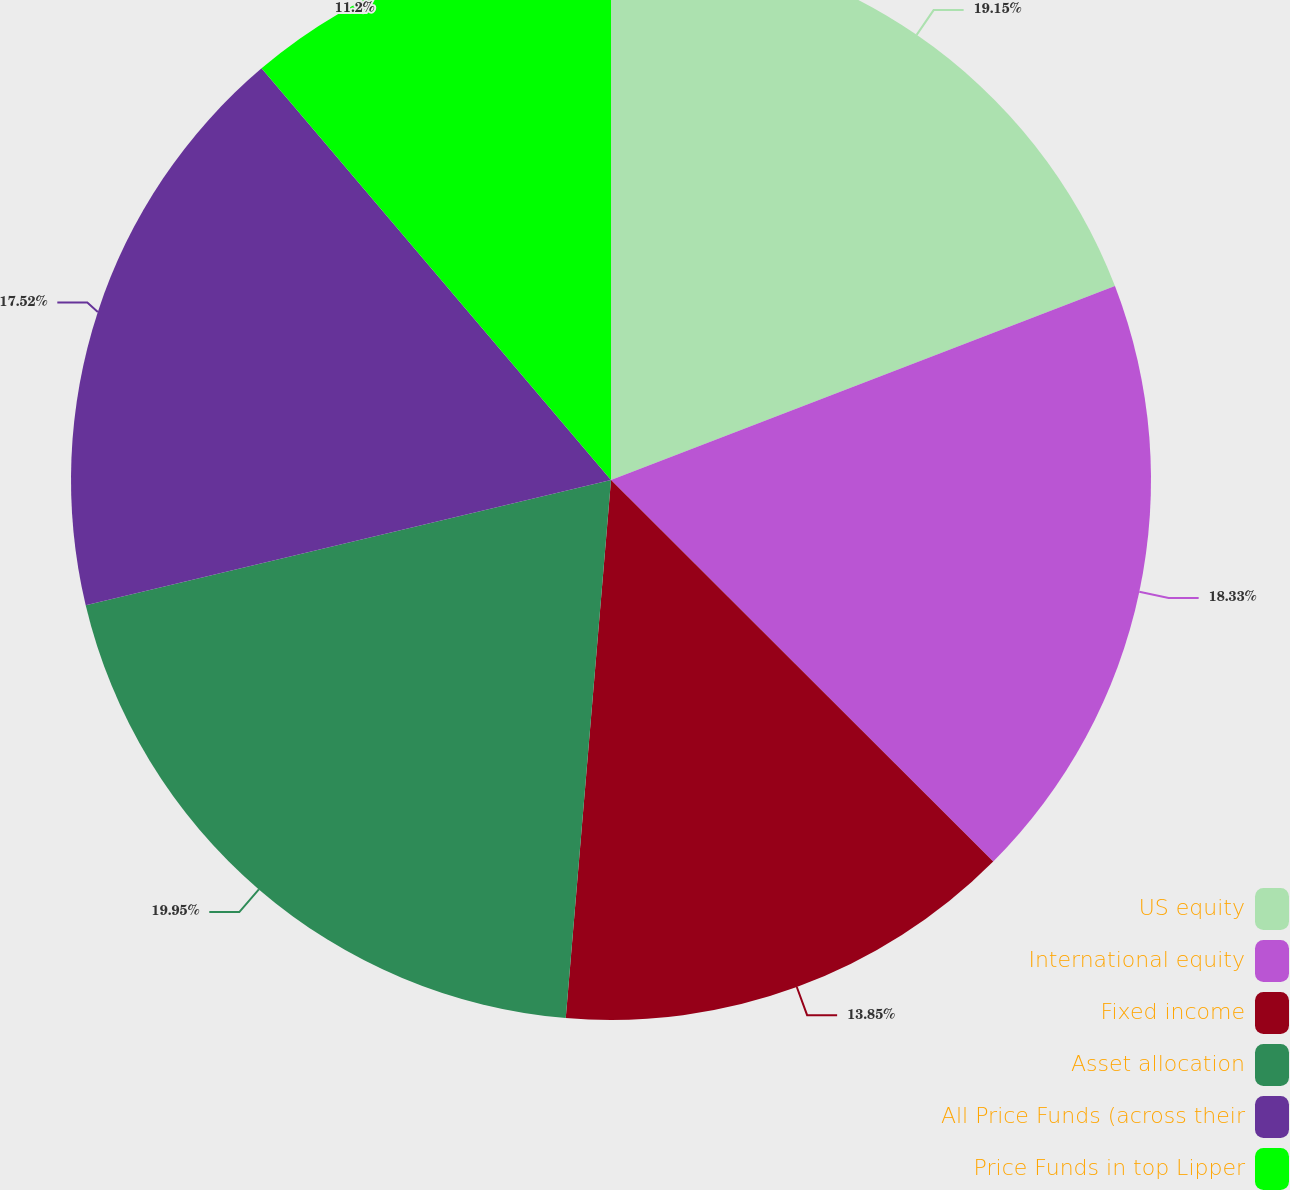Convert chart to OTSL. <chart><loc_0><loc_0><loc_500><loc_500><pie_chart><fcel>US equity<fcel>International equity<fcel>Fixed income<fcel>Asset allocation<fcel>All Price Funds (across their<fcel>Price Funds in top Lipper<nl><fcel>19.15%<fcel>18.33%<fcel>13.85%<fcel>19.94%<fcel>17.52%<fcel>11.2%<nl></chart> 